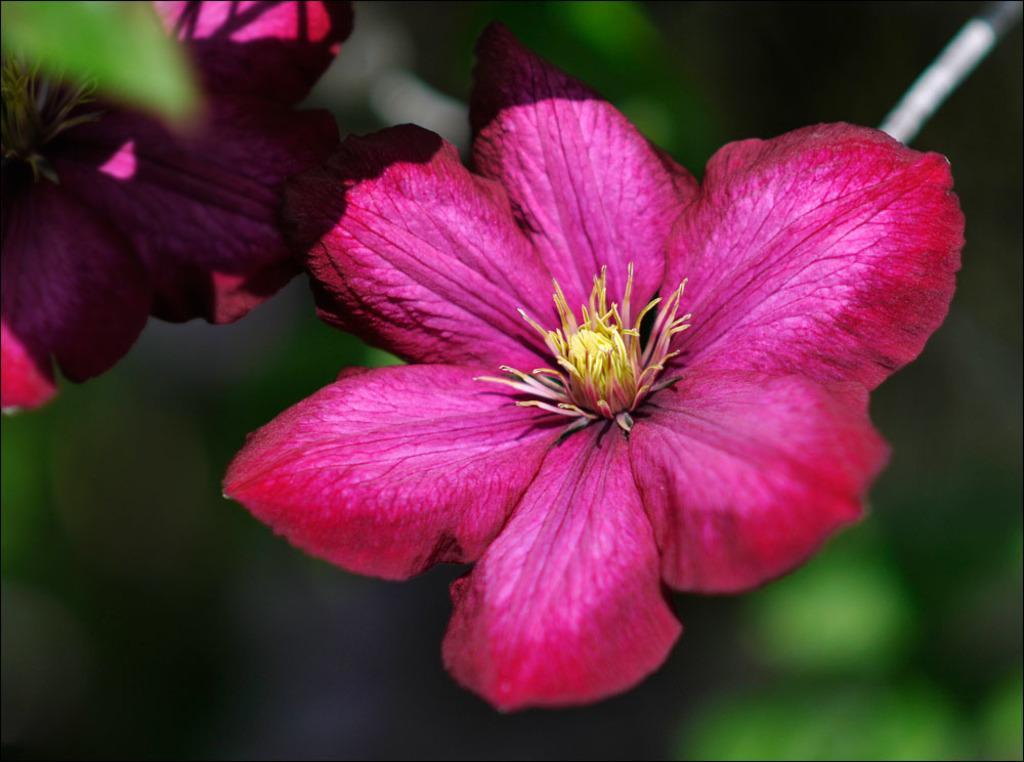Could you give a brief overview of what you see in this image? In this picture I can see pink color flowers. The background of the image is blurred. 